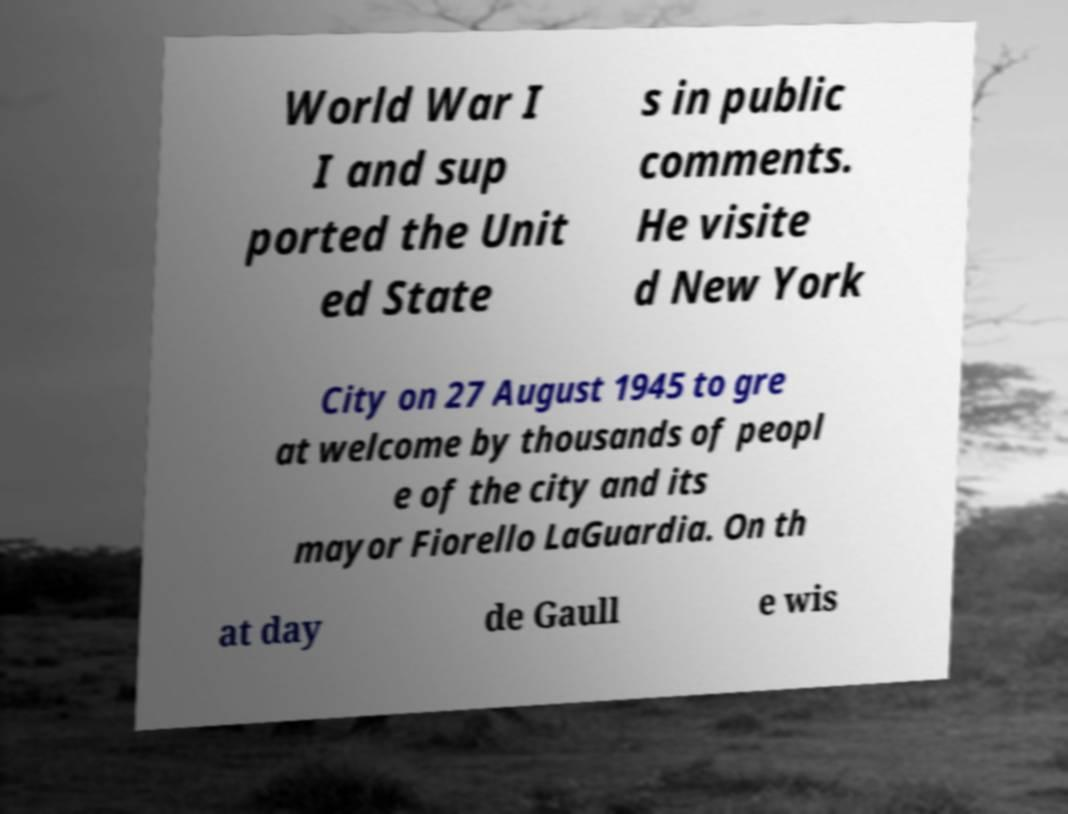Can you read and provide the text displayed in the image?This photo seems to have some interesting text. Can you extract and type it out for me? World War I I and sup ported the Unit ed State s in public comments. He visite d New York City on 27 August 1945 to gre at welcome by thousands of peopl e of the city and its mayor Fiorello LaGuardia. On th at day de Gaull e wis 